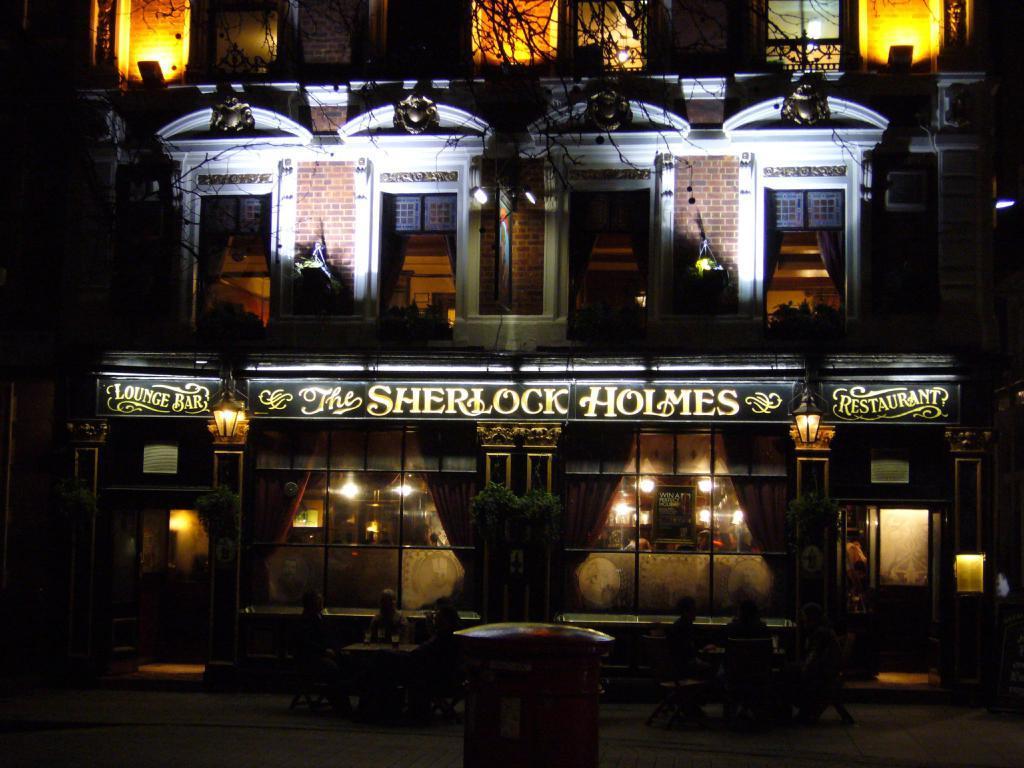How would you summarize this image in a sentence or two? In the picture I can see a building which has windows, lights, boards which has something written on them, a tree and some other objects. This image is little bit dark. 